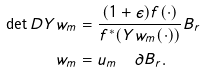Convert formula to latex. <formula><loc_0><loc_0><loc_500><loc_500>\det D Y w _ { m } & = \frac { ( 1 + \epsilon ) f ( \cdot ) } { f ^ { * } ( Y w _ { m } ( \cdot ) ) } B _ { r } \\ w _ { m } & = u _ { m } \quad \partial B _ { r } .</formula> 